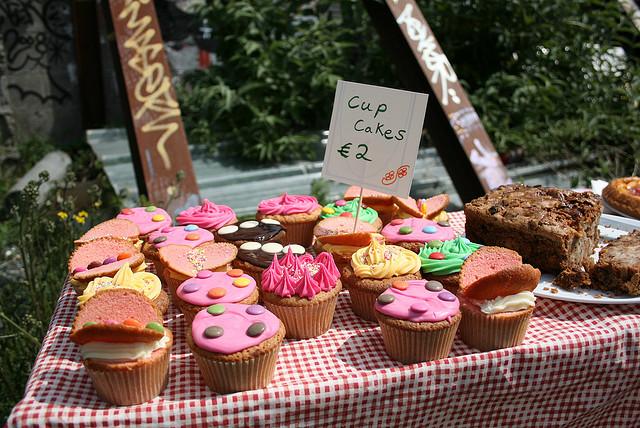Is this a sale?
Answer briefly. Yes. How much do the cupcakes cost?
Give a very brief answer. 2. How many cupcakes?
Write a very short answer. 22. 